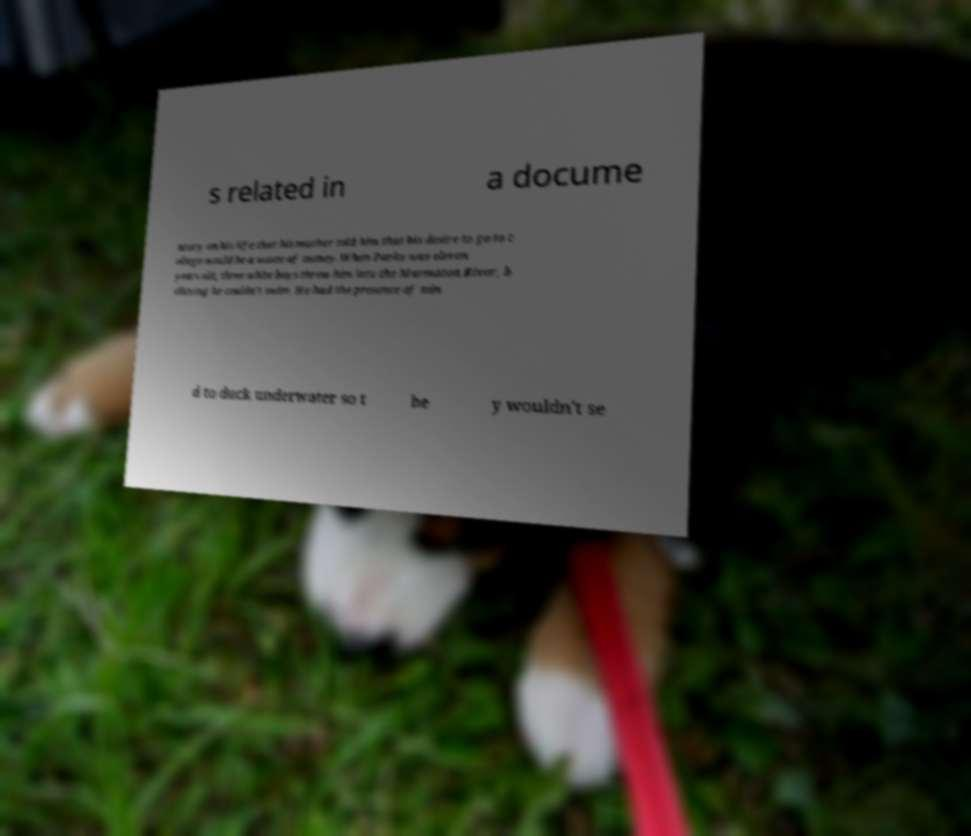Can you accurately transcribe the text from the provided image for me? s related in a docume ntary on his life that his teacher told him that his desire to go to c ollege would be a waste of money.When Parks was eleven years old, three white boys threw him into the Marmaton River, b elieving he couldn't swim. He had the presence of min d to duck underwater so t he y wouldn't se 